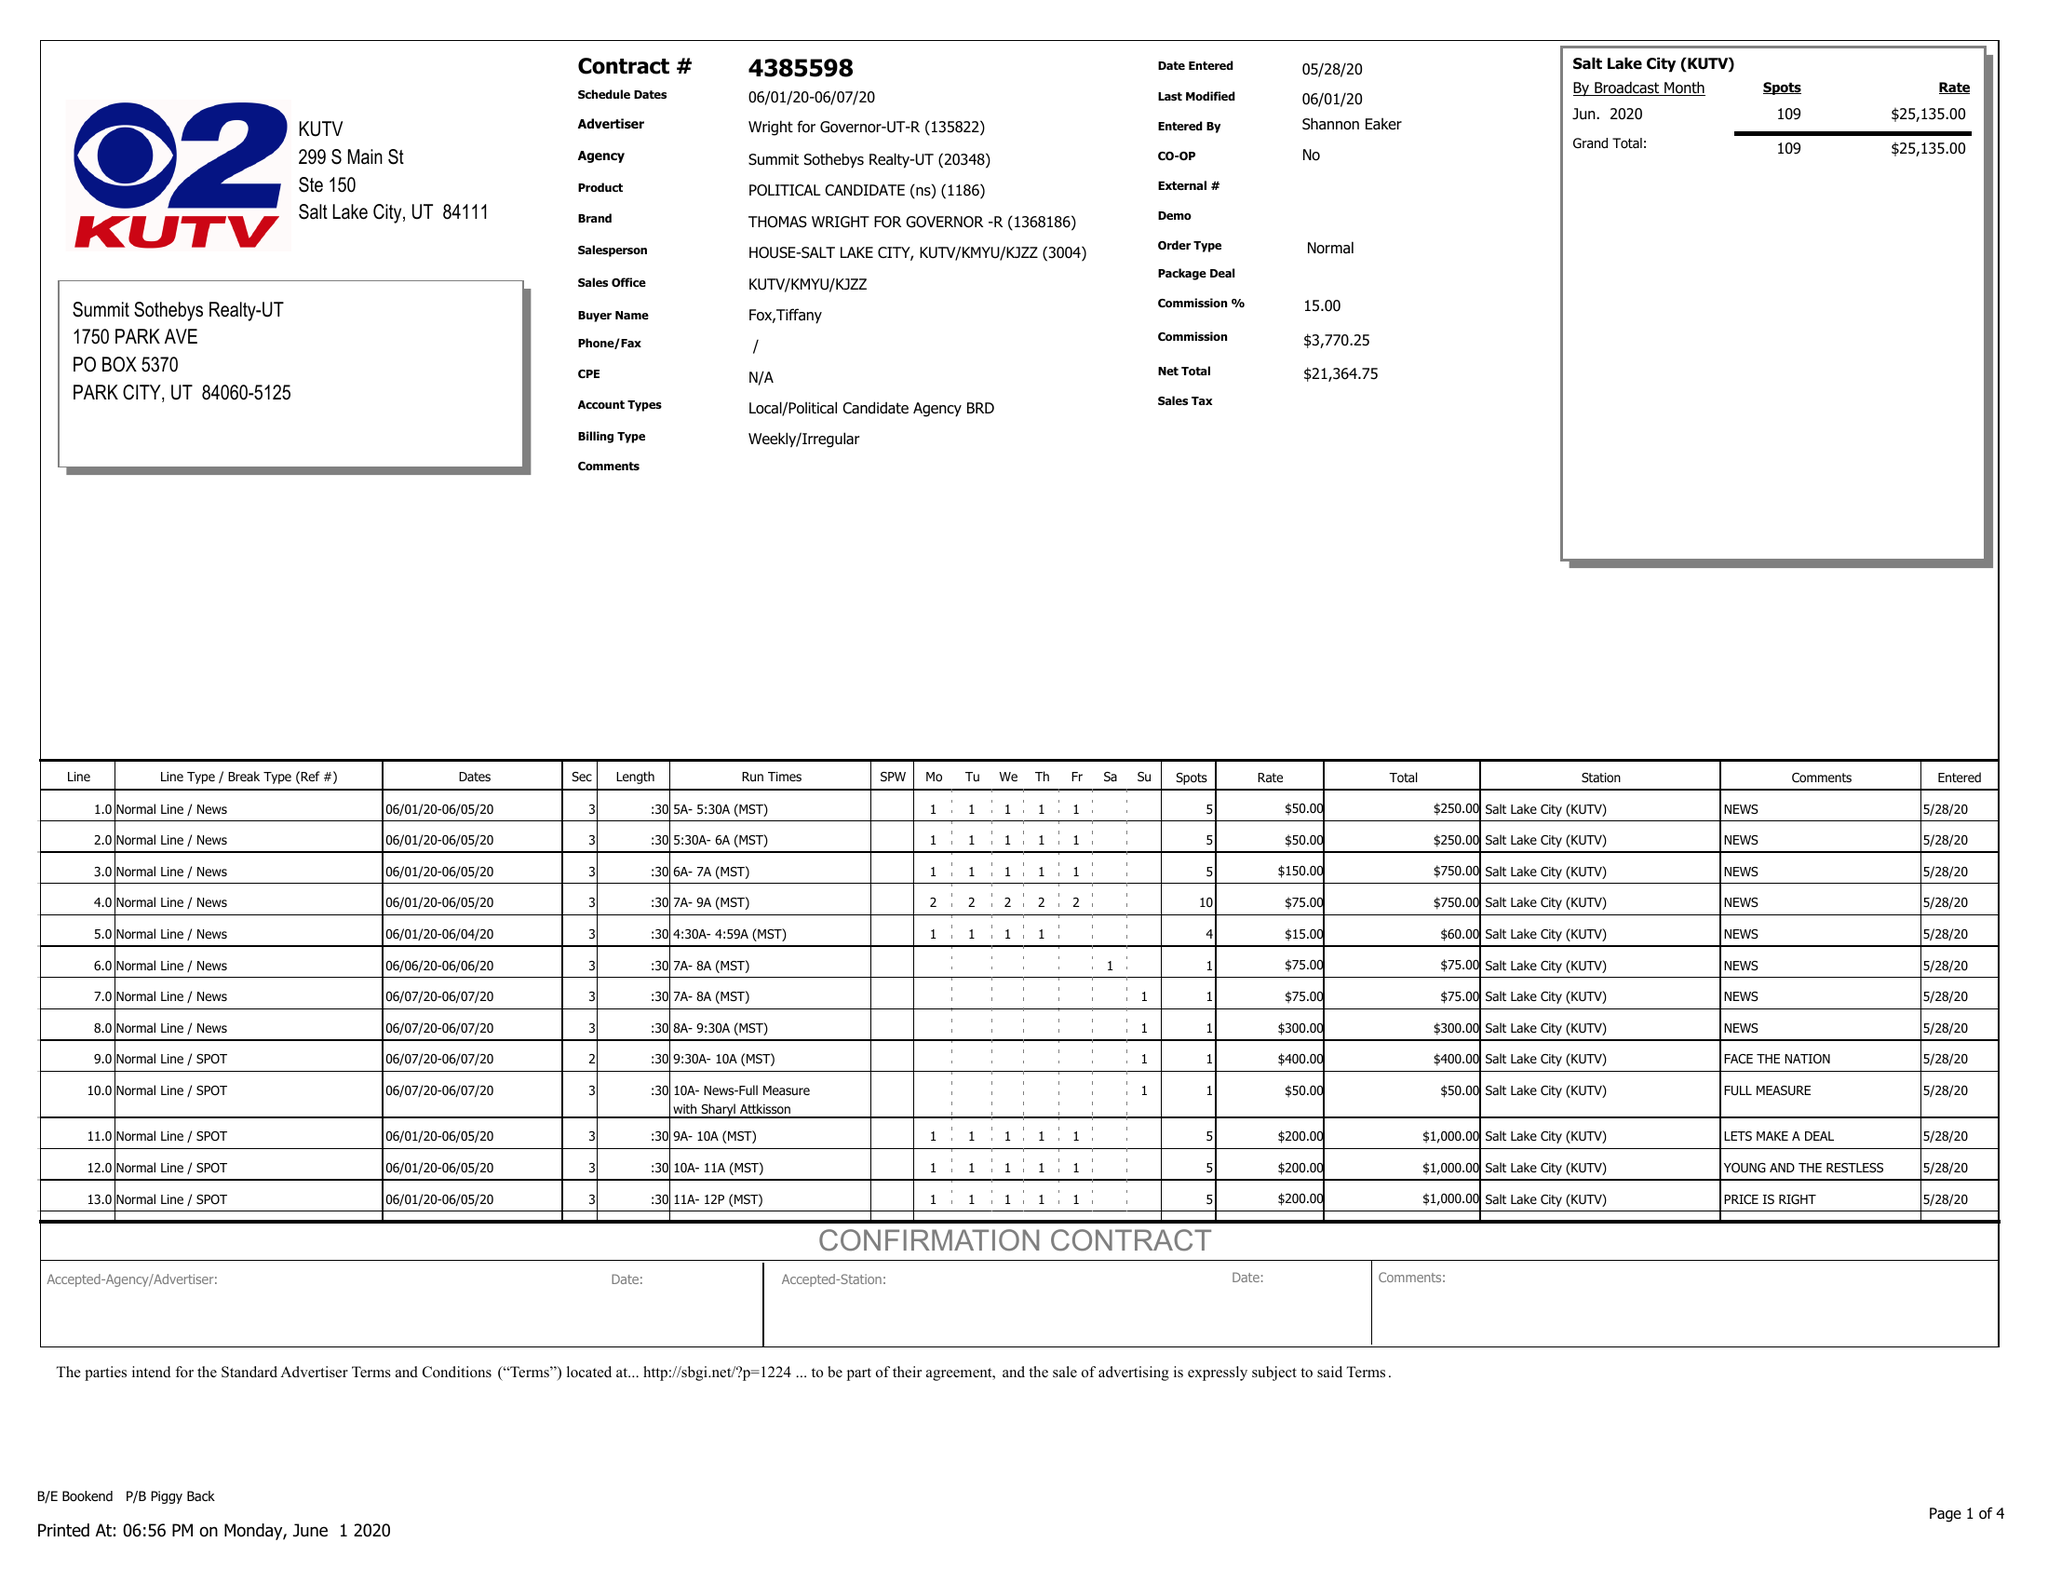What is the value for the gross_amount?
Answer the question using a single word or phrase. 25135.00 